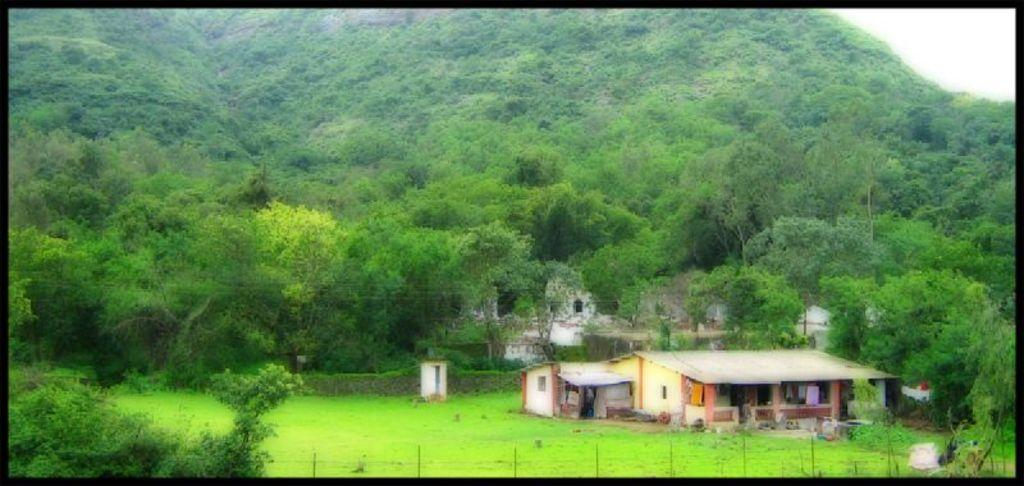What type of structures can be seen in the image? There are houses in the image. What type of vegetation is present in the image? There is grass, plants, and trees in the image. What is visible at the top of the image? The sky is visible at the top of the image. What is the father doing in the image? There is no father present in the image. What force is acting on the trees in the image? There is no force acting on the trees in the image; they are stationary. 